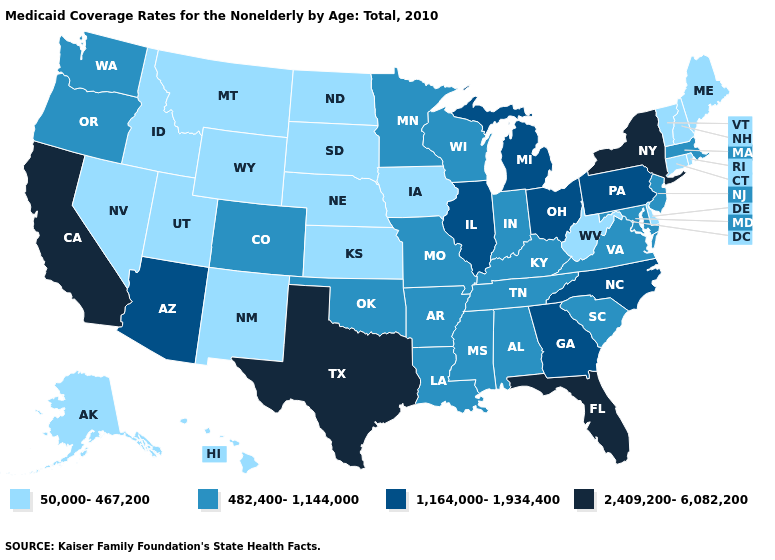Does the first symbol in the legend represent the smallest category?
Short answer required. Yes. Name the states that have a value in the range 2,409,200-6,082,200?
Be succinct. California, Florida, New York, Texas. What is the highest value in the MidWest ?
Give a very brief answer. 1,164,000-1,934,400. Which states have the highest value in the USA?
Give a very brief answer. California, Florida, New York, Texas. Which states hav the highest value in the West?
Keep it brief. California. Which states have the lowest value in the MidWest?
Quick response, please. Iowa, Kansas, Nebraska, North Dakota, South Dakota. How many symbols are there in the legend?
Be succinct. 4. Name the states that have a value in the range 1,164,000-1,934,400?
Short answer required. Arizona, Georgia, Illinois, Michigan, North Carolina, Ohio, Pennsylvania. Does Minnesota have the highest value in the MidWest?
Quick response, please. No. Does New York have the highest value in the Northeast?
Short answer required. Yes. What is the value of West Virginia?
Concise answer only. 50,000-467,200. Which states have the highest value in the USA?
Quick response, please. California, Florida, New York, Texas. What is the value of New York?
Concise answer only. 2,409,200-6,082,200. Name the states that have a value in the range 1,164,000-1,934,400?
Answer briefly. Arizona, Georgia, Illinois, Michigan, North Carolina, Ohio, Pennsylvania. Name the states that have a value in the range 50,000-467,200?
Concise answer only. Alaska, Connecticut, Delaware, Hawaii, Idaho, Iowa, Kansas, Maine, Montana, Nebraska, Nevada, New Hampshire, New Mexico, North Dakota, Rhode Island, South Dakota, Utah, Vermont, West Virginia, Wyoming. 